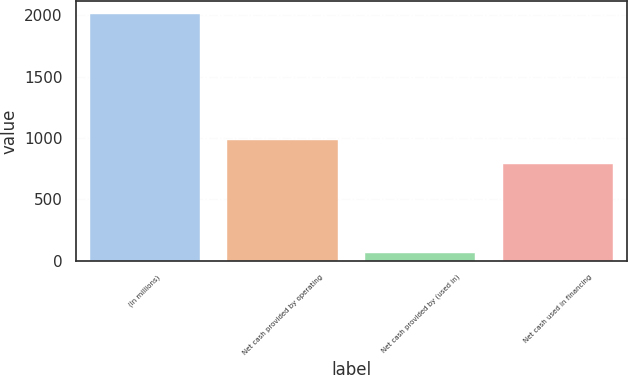Convert chart to OTSL. <chart><loc_0><loc_0><loc_500><loc_500><bar_chart><fcel>(In millions)<fcel>Net cash provided by operating<fcel>Net cash provided by (used in)<fcel>Net cash used in financing<nl><fcel>2015<fcel>984.2<fcel>60<fcel>788.7<nl></chart> 